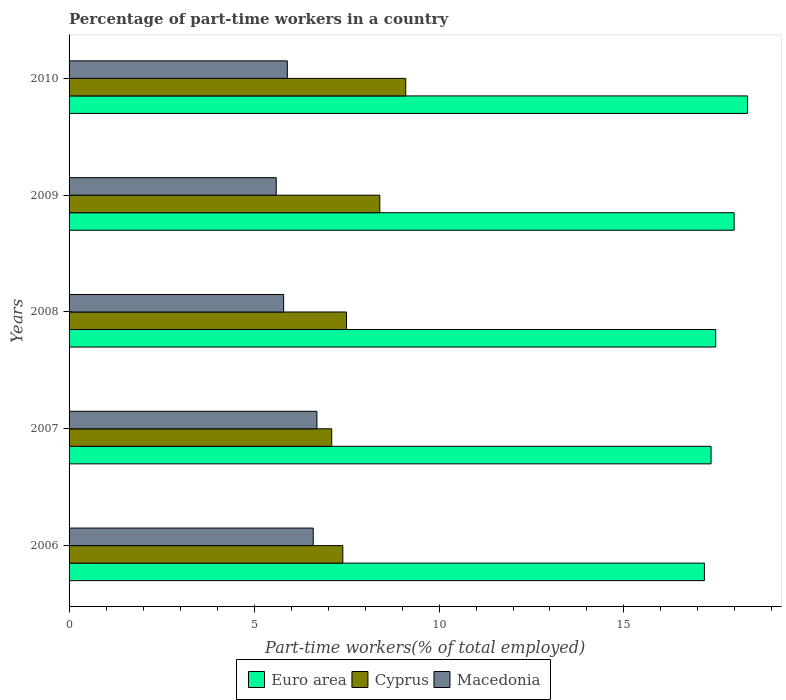Are the number of bars on each tick of the Y-axis equal?
Provide a succinct answer. Yes. How many bars are there on the 3rd tick from the bottom?
Provide a succinct answer. 3. In how many cases, is the number of bars for a given year not equal to the number of legend labels?
Your answer should be very brief. 0. What is the percentage of part-time workers in Euro area in 2010?
Give a very brief answer. 18.34. Across all years, what is the maximum percentage of part-time workers in Cyprus?
Make the answer very short. 9.1. Across all years, what is the minimum percentage of part-time workers in Euro area?
Give a very brief answer. 17.17. What is the total percentage of part-time workers in Macedonia in the graph?
Provide a succinct answer. 30.6. What is the difference between the percentage of part-time workers in Macedonia in 2009 and that in 2010?
Your response must be concise. -0.3. What is the difference between the percentage of part-time workers in Cyprus in 2009 and the percentage of part-time workers in Euro area in 2008?
Offer a terse response. -9.08. What is the average percentage of part-time workers in Macedonia per year?
Your response must be concise. 6.12. In the year 2007, what is the difference between the percentage of part-time workers in Macedonia and percentage of part-time workers in Cyprus?
Offer a very short reply. -0.4. What is the ratio of the percentage of part-time workers in Euro area in 2006 to that in 2009?
Provide a succinct answer. 0.96. Is the percentage of part-time workers in Cyprus in 2009 less than that in 2010?
Your answer should be very brief. Yes. What is the difference between the highest and the second highest percentage of part-time workers in Cyprus?
Your answer should be very brief. 0.7. What is the difference between the highest and the lowest percentage of part-time workers in Cyprus?
Your answer should be very brief. 2. In how many years, is the percentage of part-time workers in Euro area greater than the average percentage of part-time workers in Euro area taken over all years?
Offer a terse response. 2. What does the 3rd bar from the bottom in 2008 represents?
Offer a very short reply. Macedonia. Is it the case that in every year, the sum of the percentage of part-time workers in Euro area and percentage of part-time workers in Cyprus is greater than the percentage of part-time workers in Macedonia?
Provide a short and direct response. Yes. Are all the bars in the graph horizontal?
Keep it short and to the point. Yes. Are the values on the major ticks of X-axis written in scientific E-notation?
Offer a terse response. No. Where does the legend appear in the graph?
Your answer should be very brief. Bottom center. How are the legend labels stacked?
Ensure brevity in your answer.  Horizontal. What is the title of the graph?
Keep it short and to the point. Percentage of part-time workers in a country. What is the label or title of the X-axis?
Your answer should be very brief. Part-time workers(% of total employed). What is the Part-time workers(% of total employed) of Euro area in 2006?
Keep it short and to the point. 17.17. What is the Part-time workers(% of total employed) of Cyprus in 2006?
Give a very brief answer. 7.4. What is the Part-time workers(% of total employed) in Macedonia in 2006?
Your answer should be compact. 6.6. What is the Part-time workers(% of total employed) of Euro area in 2007?
Provide a succinct answer. 17.35. What is the Part-time workers(% of total employed) of Cyprus in 2007?
Ensure brevity in your answer.  7.1. What is the Part-time workers(% of total employed) in Macedonia in 2007?
Ensure brevity in your answer.  6.7. What is the Part-time workers(% of total employed) of Euro area in 2008?
Your answer should be compact. 17.48. What is the Part-time workers(% of total employed) of Macedonia in 2008?
Ensure brevity in your answer.  5.8. What is the Part-time workers(% of total employed) in Euro area in 2009?
Your answer should be very brief. 17.98. What is the Part-time workers(% of total employed) of Cyprus in 2009?
Ensure brevity in your answer.  8.4. What is the Part-time workers(% of total employed) of Macedonia in 2009?
Make the answer very short. 5.6. What is the Part-time workers(% of total employed) in Euro area in 2010?
Provide a succinct answer. 18.34. What is the Part-time workers(% of total employed) in Cyprus in 2010?
Offer a very short reply. 9.1. What is the Part-time workers(% of total employed) of Macedonia in 2010?
Give a very brief answer. 5.9. Across all years, what is the maximum Part-time workers(% of total employed) of Euro area?
Your answer should be very brief. 18.34. Across all years, what is the maximum Part-time workers(% of total employed) in Cyprus?
Give a very brief answer. 9.1. Across all years, what is the maximum Part-time workers(% of total employed) in Macedonia?
Ensure brevity in your answer.  6.7. Across all years, what is the minimum Part-time workers(% of total employed) in Euro area?
Provide a succinct answer. 17.17. Across all years, what is the minimum Part-time workers(% of total employed) in Cyprus?
Make the answer very short. 7.1. Across all years, what is the minimum Part-time workers(% of total employed) of Macedonia?
Ensure brevity in your answer.  5.6. What is the total Part-time workers(% of total employed) in Euro area in the graph?
Ensure brevity in your answer.  88.33. What is the total Part-time workers(% of total employed) of Cyprus in the graph?
Keep it short and to the point. 39.5. What is the total Part-time workers(% of total employed) of Macedonia in the graph?
Your answer should be very brief. 30.6. What is the difference between the Part-time workers(% of total employed) of Euro area in 2006 and that in 2007?
Make the answer very short. -0.18. What is the difference between the Part-time workers(% of total employed) of Cyprus in 2006 and that in 2007?
Make the answer very short. 0.3. What is the difference between the Part-time workers(% of total employed) of Euro area in 2006 and that in 2008?
Your response must be concise. -0.31. What is the difference between the Part-time workers(% of total employed) in Cyprus in 2006 and that in 2008?
Your answer should be very brief. -0.1. What is the difference between the Part-time workers(% of total employed) in Macedonia in 2006 and that in 2008?
Offer a terse response. 0.8. What is the difference between the Part-time workers(% of total employed) of Euro area in 2006 and that in 2009?
Provide a short and direct response. -0.8. What is the difference between the Part-time workers(% of total employed) in Cyprus in 2006 and that in 2009?
Your answer should be very brief. -1. What is the difference between the Part-time workers(% of total employed) in Euro area in 2006 and that in 2010?
Ensure brevity in your answer.  -1.17. What is the difference between the Part-time workers(% of total employed) of Euro area in 2007 and that in 2008?
Keep it short and to the point. -0.13. What is the difference between the Part-time workers(% of total employed) of Macedonia in 2007 and that in 2008?
Offer a terse response. 0.9. What is the difference between the Part-time workers(% of total employed) in Euro area in 2007 and that in 2009?
Your response must be concise. -0.62. What is the difference between the Part-time workers(% of total employed) in Cyprus in 2007 and that in 2009?
Provide a short and direct response. -1.3. What is the difference between the Part-time workers(% of total employed) of Macedonia in 2007 and that in 2009?
Your response must be concise. 1.1. What is the difference between the Part-time workers(% of total employed) in Euro area in 2007 and that in 2010?
Your response must be concise. -0.99. What is the difference between the Part-time workers(% of total employed) of Euro area in 2008 and that in 2009?
Ensure brevity in your answer.  -0.5. What is the difference between the Part-time workers(% of total employed) of Cyprus in 2008 and that in 2009?
Provide a short and direct response. -0.9. What is the difference between the Part-time workers(% of total employed) of Euro area in 2008 and that in 2010?
Offer a very short reply. -0.86. What is the difference between the Part-time workers(% of total employed) in Cyprus in 2008 and that in 2010?
Give a very brief answer. -1.6. What is the difference between the Part-time workers(% of total employed) of Macedonia in 2008 and that in 2010?
Make the answer very short. -0.1. What is the difference between the Part-time workers(% of total employed) of Euro area in 2009 and that in 2010?
Make the answer very short. -0.36. What is the difference between the Part-time workers(% of total employed) of Macedonia in 2009 and that in 2010?
Your response must be concise. -0.3. What is the difference between the Part-time workers(% of total employed) in Euro area in 2006 and the Part-time workers(% of total employed) in Cyprus in 2007?
Ensure brevity in your answer.  10.07. What is the difference between the Part-time workers(% of total employed) in Euro area in 2006 and the Part-time workers(% of total employed) in Macedonia in 2007?
Offer a very short reply. 10.47. What is the difference between the Part-time workers(% of total employed) of Cyprus in 2006 and the Part-time workers(% of total employed) of Macedonia in 2007?
Your answer should be compact. 0.7. What is the difference between the Part-time workers(% of total employed) of Euro area in 2006 and the Part-time workers(% of total employed) of Cyprus in 2008?
Give a very brief answer. 9.67. What is the difference between the Part-time workers(% of total employed) of Euro area in 2006 and the Part-time workers(% of total employed) of Macedonia in 2008?
Your answer should be compact. 11.37. What is the difference between the Part-time workers(% of total employed) of Euro area in 2006 and the Part-time workers(% of total employed) of Cyprus in 2009?
Your response must be concise. 8.77. What is the difference between the Part-time workers(% of total employed) of Euro area in 2006 and the Part-time workers(% of total employed) of Macedonia in 2009?
Your answer should be very brief. 11.57. What is the difference between the Part-time workers(% of total employed) of Euro area in 2006 and the Part-time workers(% of total employed) of Cyprus in 2010?
Offer a terse response. 8.07. What is the difference between the Part-time workers(% of total employed) of Euro area in 2006 and the Part-time workers(% of total employed) of Macedonia in 2010?
Your answer should be compact. 11.27. What is the difference between the Part-time workers(% of total employed) of Cyprus in 2006 and the Part-time workers(% of total employed) of Macedonia in 2010?
Ensure brevity in your answer.  1.5. What is the difference between the Part-time workers(% of total employed) of Euro area in 2007 and the Part-time workers(% of total employed) of Cyprus in 2008?
Keep it short and to the point. 9.85. What is the difference between the Part-time workers(% of total employed) of Euro area in 2007 and the Part-time workers(% of total employed) of Macedonia in 2008?
Ensure brevity in your answer.  11.55. What is the difference between the Part-time workers(% of total employed) of Euro area in 2007 and the Part-time workers(% of total employed) of Cyprus in 2009?
Ensure brevity in your answer.  8.95. What is the difference between the Part-time workers(% of total employed) in Euro area in 2007 and the Part-time workers(% of total employed) in Macedonia in 2009?
Offer a very short reply. 11.75. What is the difference between the Part-time workers(% of total employed) in Euro area in 2007 and the Part-time workers(% of total employed) in Cyprus in 2010?
Offer a terse response. 8.25. What is the difference between the Part-time workers(% of total employed) of Euro area in 2007 and the Part-time workers(% of total employed) of Macedonia in 2010?
Offer a very short reply. 11.45. What is the difference between the Part-time workers(% of total employed) in Cyprus in 2007 and the Part-time workers(% of total employed) in Macedonia in 2010?
Provide a short and direct response. 1.2. What is the difference between the Part-time workers(% of total employed) of Euro area in 2008 and the Part-time workers(% of total employed) of Cyprus in 2009?
Ensure brevity in your answer.  9.08. What is the difference between the Part-time workers(% of total employed) of Euro area in 2008 and the Part-time workers(% of total employed) of Macedonia in 2009?
Offer a very short reply. 11.88. What is the difference between the Part-time workers(% of total employed) in Euro area in 2008 and the Part-time workers(% of total employed) in Cyprus in 2010?
Keep it short and to the point. 8.38. What is the difference between the Part-time workers(% of total employed) of Euro area in 2008 and the Part-time workers(% of total employed) of Macedonia in 2010?
Ensure brevity in your answer.  11.58. What is the difference between the Part-time workers(% of total employed) of Cyprus in 2008 and the Part-time workers(% of total employed) of Macedonia in 2010?
Give a very brief answer. 1.6. What is the difference between the Part-time workers(% of total employed) of Euro area in 2009 and the Part-time workers(% of total employed) of Cyprus in 2010?
Keep it short and to the point. 8.88. What is the difference between the Part-time workers(% of total employed) in Euro area in 2009 and the Part-time workers(% of total employed) in Macedonia in 2010?
Provide a succinct answer. 12.08. What is the difference between the Part-time workers(% of total employed) of Cyprus in 2009 and the Part-time workers(% of total employed) of Macedonia in 2010?
Ensure brevity in your answer.  2.5. What is the average Part-time workers(% of total employed) in Euro area per year?
Offer a terse response. 17.67. What is the average Part-time workers(% of total employed) of Macedonia per year?
Your answer should be compact. 6.12. In the year 2006, what is the difference between the Part-time workers(% of total employed) of Euro area and Part-time workers(% of total employed) of Cyprus?
Your response must be concise. 9.77. In the year 2006, what is the difference between the Part-time workers(% of total employed) in Euro area and Part-time workers(% of total employed) in Macedonia?
Provide a short and direct response. 10.57. In the year 2007, what is the difference between the Part-time workers(% of total employed) of Euro area and Part-time workers(% of total employed) of Cyprus?
Your answer should be compact. 10.25. In the year 2007, what is the difference between the Part-time workers(% of total employed) of Euro area and Part-time workers(% of total employed) of Macedonia?
Provide a succinct answer. 10.65. In the year 2008, what is the difference between the Part-time workers(% of total employed) in Euro area and Part-time workers(% of total employed) in Cyprus?
Offer a terse response. 9.98. In the year 2008, what is the difference between the Part-time workers(% of total employed) in Euro area and Part-time workers(% of total employed) in Macedonia?
Ensure brevity in your answer.  11.68. In the year 2009, what is the difference between the Part-time workers(% of total employed) of Euro area and Part-time workers(% of total employed) of Cyprus?
Your answer should be compact. 9.58. In the year 2009, what is the difference between the Part-time workers(% of total employed) of Euro area and Part-time workers(% of total employed) of Macedonia?
Your response must be concise. 12.38. In the year 2009, what is the difference between the Part-time workers(% of total employed) in Cyprus and Part-time workers(% of total employed) in Macedonia?
Ensure brevity in your answer.  2.8. In the year 2010, what is the difference between the Part-time workers(% of total employed) of Euro area and Part-time workers(% of total employed) of Cyprus?
Offer a very short reply. 9.24. In the year 2010, what is the difference between the Part-time workers(% of total employed) in Euro area and Part-time workers(% of total employed) in Macedonia?
Your answer should be very brief. 12.44. In the year 2010, what is the difference between the Part-time workers(% of total employed) in Cyprus and Part-time workers(% of total employed) in Macedonia?
Keep it short and to the point. 3.2. What is the ratio of the Part-time workers(% of total employed) in Cyprus in 2006 to that in 2007?
Your response must be concise. 1.04. What is the ratio of the Part-time workers(% of total employed) of Macedonia in 2006 to that in 2007?
Offer a terse response. 0.99. What is the ratio of the Part-time workers(% of total employed) in Euro area in 2006 to that in 2008?
Provide a succinct answer. 0.98. What is the ratio of the Part-time workers(% of total employed) in Cyprus in 2006 to that in 2008?
Ensure brevity in your answer.  0.99. What is the ratio of the Part-time workers(% of total employed) of Macedonia in 2006 to that in 2008?
Give a very brief answer. 1.14. What is the ratio of the Part-time workers(% of total employed) in Euro area in 2006 to that in 2009?
Ensure brevity in your answer.  0.96. What is the ratio of the Part-time workers(% of total employed) in Cyprus in 2006 to that in 2009?
Offer a very short reply. 0.88. What is the ratio of the Part-time workers(% of total employed) of Macedonia in 2006 to that in 2009?
Your answer should be very brief. 1.18. What is the ratio of the Part-time workers(% of total employed) of Euro area in 2006 to that in 2010?
Ensure brevity in your answer.  0.94. What is the ratio of the Part-time workers(% of total employed) in Cyprus in 2006 to that in 2010?
Offer a very short reply. 0.81. What is the ratio of the Part-time workers(% of total employed) in Macedonia in 2006 to that in 2010?
Your response must be concise. 1.12. What is the ratio of the Part-time workers(% of total employed) of Euro area in 2007 to that in 2008?
Keep it short and to the point. 0.99. What is the ratio of the Part-time workers(% of total employed) in Cyprus in 2007 to that in 2008?
Your response must be concise. 0.95. What is the ratio of the Part-time workers(% of total employed) in Macedonia in 2007 to that in 2008?
Provide a succinct answer. 1.16. What is the ratio of the Part-time workers(% of total employed) of Euro area in 2007 to that in 2009?
Give a very brief answer. 0.97. What is the ratio of the Part-time workers(% of total employed) of Cyprus in 2007 to that in 2009?
Provide a succinct answer. 0.85. What is the ratio of the Part-time workers(% of total employed) of Macedonia in 2007 to that in 2009?
Provide a short and direct response. 1.2. What is the ratio of the Part-time workers(% of total employed) of Euro area in 2007 to that in 2010?
Ensure brevity in your answer.  0.95. What is the ratio of the Part-time workers(% of total employed) in Cyprus in 2007 to that in 2010?
Your answer should be compact. 0.78. What is the ratio of the Part-time workers(% of total employed) of Macedonia in 2007 to that in 2010?
Give a very brief answer. 1.14. What is the ratio of the Part-time workers(% of total employed) of Euro area in 2008 to that in 2009?
Make the answer very short. 0.97. What is the ratio of the Part-time workers(% of total employed) of Cyprus in 2008 to that in 2009?
Offer a terse response. 0.89. What is the ratio of the Part-time workers(% of total employed) of Macedonia in 2008 to that in 2009?
Your response must be concise. 1.04. What is the ratio of the Part-time workers(% of total employed) in Euro area in 2008 to that in 2010?
Keep it short and to the point. 0.95. What is the ratio of the Part-time workers(% of total employed) of Cyprus in 2008 to that in 2010?
Keep it short and to the point. 0.82. What is the ratio of the Part-time workers(% of total employed) in Macedonia in 2008 to that in 2010?
Provide a succinct answer. 0.98. What is the ratio of the Part-time workers(% of total employed) in Euro area in 2009 to that in 2010?
Offer a terse response. 0.98. What is the ratio of the Part-time workers(% of total employed) of Macedonia in 2009 to that in 2010?
Give a very brief answer. 0.95. What is the difference between the highest and the second highest Part-time workers(% of total employed) of Euro area?
Your response must be concise. 0.36. What is the difference between the highest and the second highest Part-time workers(% of total employed) of Cyprus?
Your answer should be compact. 0.7. What is the difference between the highest and the lowest Part-time workers(% of total employed) of Euro area?
Offer a terse response. 1.17. What is the difference between the highest and the lowest Part-time workers(% of total employed) in Cyprus?
Provide a short and direct response. 2. What is the difference between the highest and the lowest Part-time workers(% of total employed) in Macedonia?
Offer a very short reply. 1.1. 